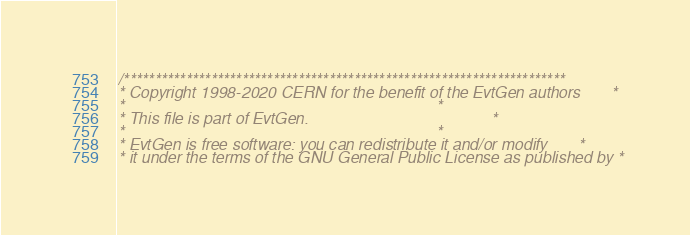Convert code to text. <code><loc_0><loc_0><loc_500><loc_500><_C++_>
/***********************************************************************
* Copyright 1998-2020 CERN for the benefit of the EvtGen authors       *
*                                                                      *
* This file is part of EvtGen.                                         *
*                                                                      *
* EvtGen is free software: you can redistribute it and/or modify       *
* it under the terms of the GNU General Public License as published by *</code> 